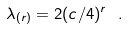Convert formula to latex. <formula><loc_0><loc_0><loc_500><loc_500>\lambda _ { ( r ) } = 2 ( c / 4 ) ^ { r } \ .</formula> 